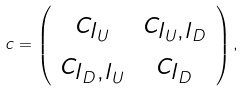Convert formula to latex. <formula><loc_0><loc_0><loc_500><loc_500>c = \left ( \begin{array} { c c } c _ { I _ { U } } & c _ { I _ { U } , I _ { D } } \\ c _ { I _ { D } , I _ { U } } & c _ { I _ { D } } \\ \end{array} \right ) ,</formula> 